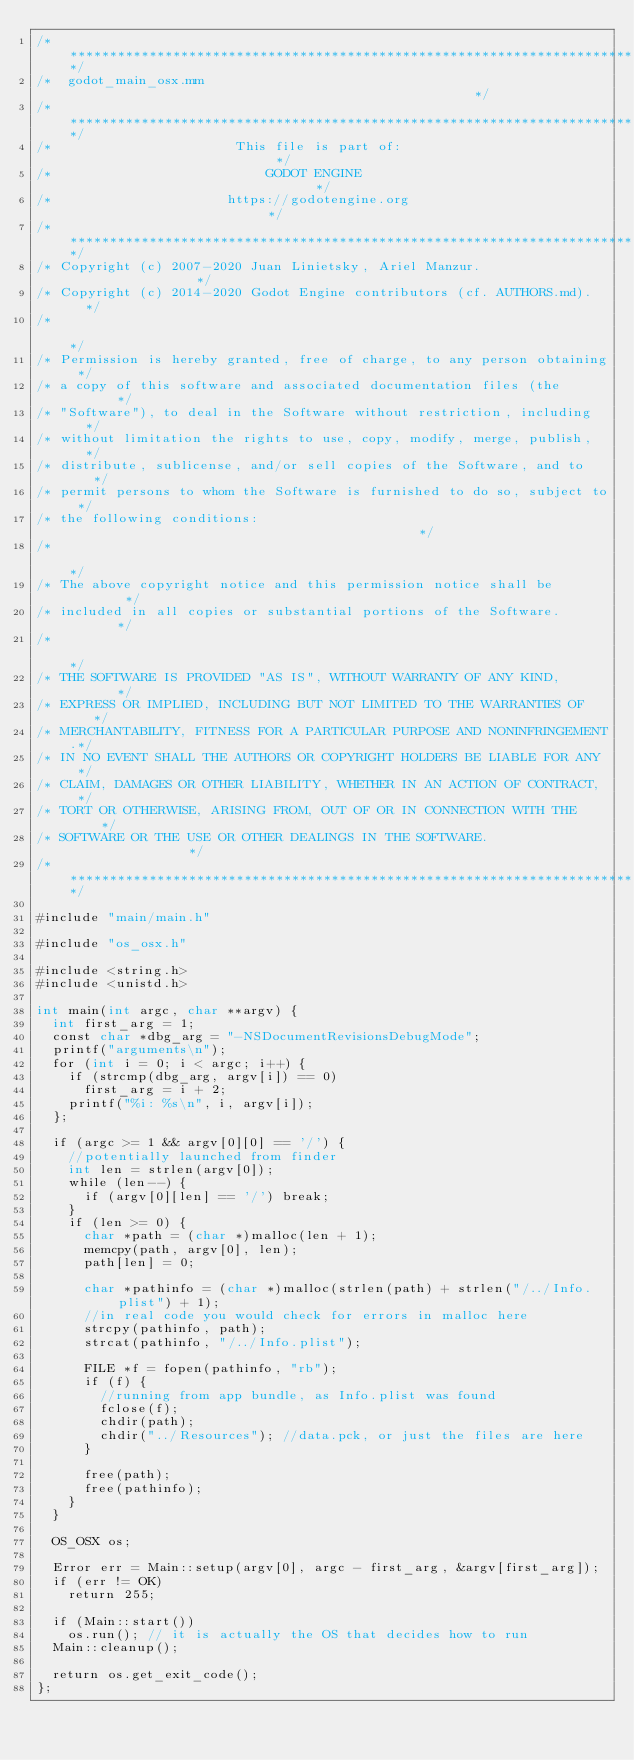Convert code to text. <code><loc_0><loc_0><loc_500><loc_500><_ObjectiveC_>/*************************************************************************/
/*  godot_main_osx.mm                                                    */
/*************************************************************************/
/*                       This file is part of:                           */
/*                           GODOT ENGINE                                */
/*                      https://godotengine.org                          */
/*************************************************************************/
/* Copyright (c) 2007-2020 Juan Linietsky, Ariel Manzur.                 */
/* Copyright (c) 2014-2020 Godot Engine contributors (cf. AUTHORS.md).   */
/*                                                                       */
/* Permission is hereby granted, free of charge, to any person obtaining */
/* a copy of this software and associated documentation files (the       */
/* "Software"), to deal in the Software without restriction, including   */
/* without limitation the rights to use, copy, modify, merge, publish,   */
/* distribute, sublicense, and/or sell copies of the Software, and to    */
/* permit persons to whom the Software is furnished to do so, subject to */
/* the following conditions:                                             */
/*                                                                       */
/* The above copyright notice and this permission notice shall be        */
/* included in all copies or substantial portions of the Software.       */
/*                                                                       */
/* THE SOFTWARE IS PROVIDED "AS IS", WITHOUT WARRANTY OF ANY KIND,       */
/* EXPRESS OR IMPLIED, INCLUDING BUT NOT LIMITED TO THE WARRANTIES OF    */
/* MERCHANTABILITY, FITNESS FOR A PARTICULAR PURPOSE AND NONINFRINGEMENT.*/
/* IN NO EVENT SHALL THE AUTHORS OR COPYRIGHT HOLDERS BE LIABLE FOR ANY  */
/* CLAIM, DAMAGES OR OTHER LIABILITY, WHETHER IN AN ACTION OF CONTRACT,  */
/* TORT OR OTHERWISE, ARISING FROM, OUT OF OR IN CONNECTION WITH THE     */
/* SOFTWARE OR THE USE OR OTHER DEALINGS IN THE SOFTWARE.                */
/*************************************************************************/

#include "main/main.h"

#include "os_osx.h"

#include <string.h>
#include <unistd.h>

int main(int argc, char **argv) {
	int first_arg = 1;
	const char *dbg_arg = "-NSDocumentRevisionsDebugMode";
	printf("arguments\n");
	for (int i = 0; i < argc; i++) {
		if (strcmp(dbg_arg, argv[i]) == 0)
			first_arg = i + 2;
		printf("%i: %s\n", i, argv[i]);
	};

	if (argc >= 1 && argv[0][0] == '/') {
		//potentially launched from finder
		int len = strlen(argv[0]);
		while (len--) {
			if (argv[0][len] == '/') break;
		}
		if (len >= 0) {
			char *path = (char *)malloc(len + 1);
			memcpy(path, argv[0], len);
			path[len] = 0;

			char *pathinfo = (char *)malloc(strlen(path) + strlen("/../Info.plist") + 1);
			//in real code you would check for errors in malloc here
			strcpy(pathinfo, path);
			strcat(pathinfo, "/../Info.plist");

			FILE *f = fopen(pathinfo, "rb");
			if (f) {
				//running from app bundle, as Info.plist was found
				fclose(f);
				chdir(path);
				chdir("../Resources"); //data.pck, or just the files are here
			}

			free(path);
			free(pathinfo);
		}
	}

	OS_OSX os;

	Error err = Main::setup(argv[0], argc - first_arg, &argv[first_arg]);
	if (err != OK)
		return 255;

	if (Main::start())
		os.run(); // it is actually the OS that decides how to run
	Main::cleanup();

	return os.get_exit_code();
};
</code> 